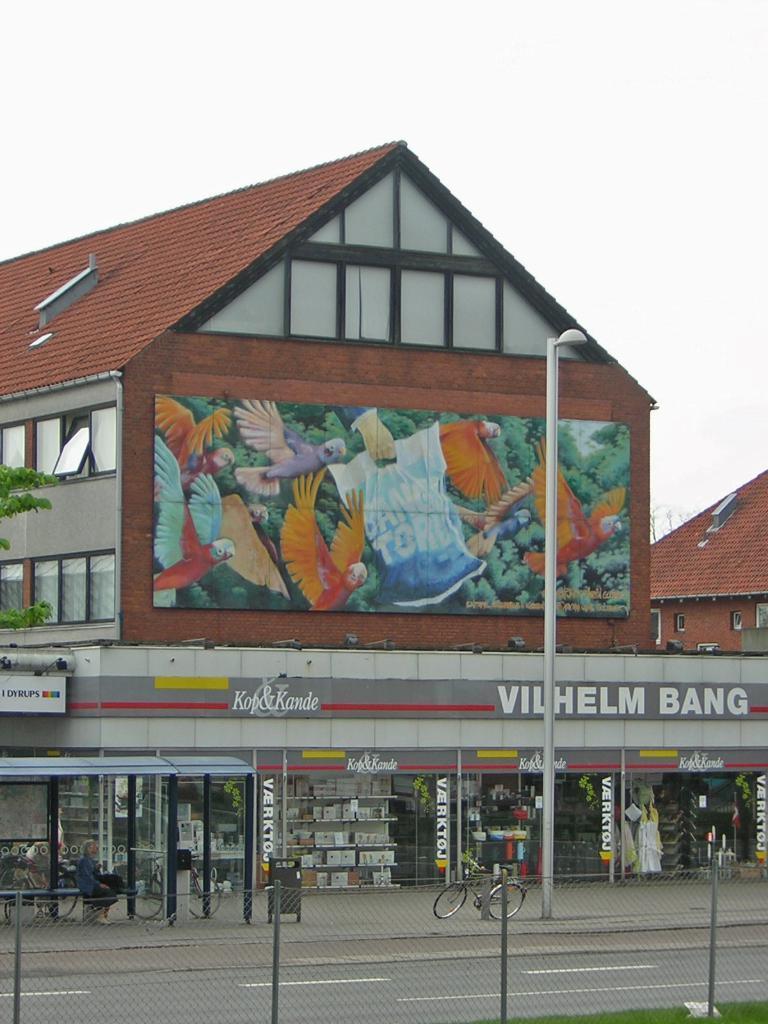Can you describe this image briefly? In the image we can see the building and the windows of the building. We can even see bicycles and a person sitting. Here we can see fence, grass and the light pole. Here we can see the text, leaves and the sky. 